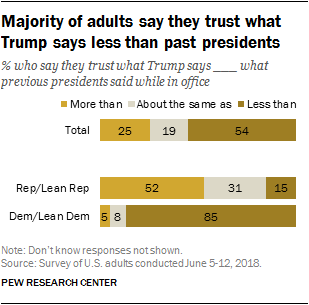Specify some key components in this picture. The value of the first orange bar is 25. Of the grey bars with a value less than 25, approximately 2 